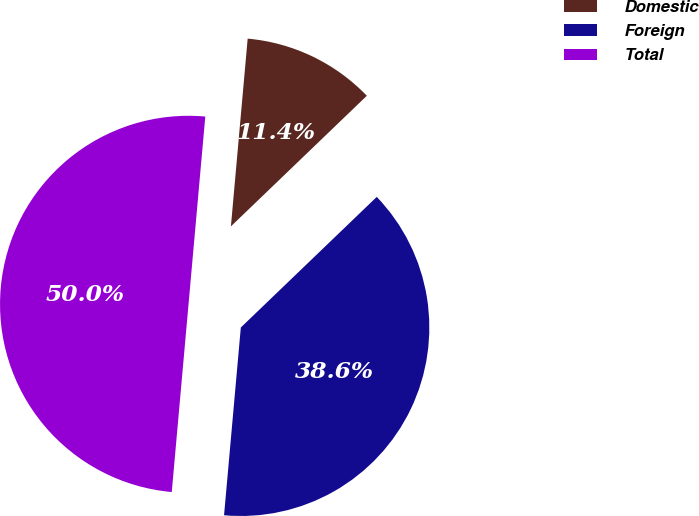<chart> <loc_0><loc_0><loc_500><loc_500><pie_chart><fcel>Domestic<fcel>Foreign<fcel>Total<nl><fcel>11.4%<fcel>38.6%<fcel>50.0%<nl></chart> 